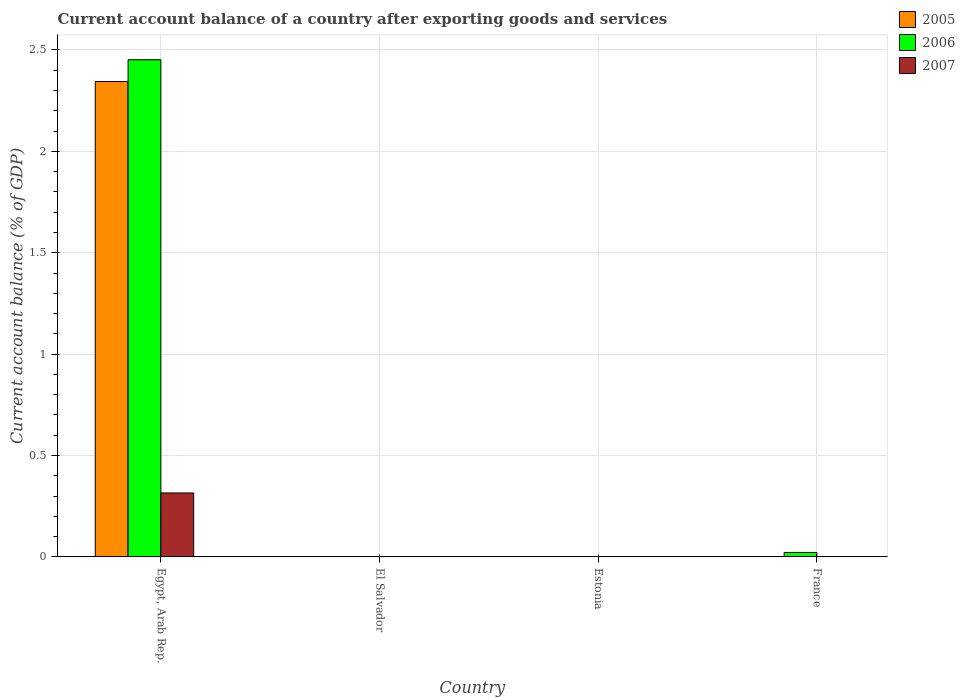How many different coloured bars are there?
Provide a succinct answer. 3. What is the label of the 2nd group of bars from the left?
Your answer should be compact. El Salvador. In how many cases, is the number of bars for a given country not equal to the number of legend labels?
Provide a succinct answer. 3. Across all countries, what is the maximum account balance in 2007?
Give a very brief answer. 0.32. Across all countries, what is the minimum account balance in 2006?
Make the answer very short. 0. In which country was the account balance in 2007 maximum?
Make the answer very short. Egypt, Arab Rep. What is the total account balance in 2006 in the graph?
Your answer should be very brief. 2.47. What is the difference between the account balance in 2006 in Egypt, Arab Rep. and that in France?
Give a very brief answer. 2.43. What is the difference between the account balance in 2005 in Estonia and the account balance in 2006 in Egypt, Arab Rep.?
Your answer should be compact. -2.45. What is the average account balance in 2006 per country?
Your answer should be compact. 0.62. What is the difference between the account balance of/in 2005 and account balance of/in 2006 in Egypt, Arab Rep.?
Provide a short and direct response. -0.11. In how many countries, is the account balance in 2005 greater than 0.2 %?
Make the answer very short. 1. What is the ratio of the account balance in 2006 in Egypt, Arab Rep. to that in France?
Offer a very short reply. 110.38. What is the difference between the highest and the lowest account balance in 2007?
Make the answer very short. 0.32. In how many countries, is the account balance in 2005 greater than the average account balance in 2005 taken over all countries?
Provide a succinct answer. 1. Is it the case that in every country, the sum of the account balance in 2005 and account balance in 2007 is greater than the account balance in 2006?
Your answer should be very brief. No. How many bars are there?
Your answer should be very brief. 4. How many countries are there in the graph?
Offer a terse response. 4. Does the graph contain grids?
Your answer should be very brief. Yes. How are the legend labels stacked?
Provide a short and direct response. Vertical. What is the title of the graph?
Make the answer very short. Current account balance of a country after exporting goods and services. Does "1999" appear as one of the legend labels in the graph?
Keep it short and to the point. No. What is the label or title of the Y-axis?
Offer a very short reply. Current account balance (% of GDP). What is the Current account balance (% of GDP) in 2005 in Egypt, Arab Rep.?
Your answer should be compact. 2.34. What is the Current account balance (% of GDP) in 2006 in Egypt, Arab Rep.?
Offer a very short reply. 2.45. What is the Current account balance (% of GDP) in 2007 in Egypt, Arab Rep.?
Your response must be concise. 0.32. What is the Current account balance (% of GDP) in 2006 in El Salvador?
Your answer should be compact. 0. What is the Current account balance (% of GDP) of 2007 in El Salvador?
Offer a terse response. 0. What is the Current account balance (% of GDP) of 2006 in Estonia?
Provide a short and direct response. 0. What is the Current account balance (% of GDP) of 2005 in France?
Give a very brief answer. 0. What is the Current account balance (% of GDP) of 2006 in France?
Give a very brief answer. 0.02. What is the Current account balance (% of GDP) in 2007 in France?
Your response must be concise. 0. Across all countries, what is the maximum Current account balance (% of GDP) of 2005?
Ensure brevity in your answer.  2.34. Across all countries, what is the maximum Current account balance (% of GDP) in 2006?
Provide a succinct answer. 2.45. Across all countries, what is the maximum Current account balance (% of GDP) of 2007?
Keep it short and to the point. 0.32. Across all countries, what is the minimum Current account balance (% of GDP) in 2005?
Your answer should be very brief. 0. Across all countries, what is the minimum Current account balance (% of GDP) of 2006?
Give a very brief answer. 0. What is the total Current account balance (% of GDP) of 2005 in the graph?
Keep it short and to the point. 2.34. What is the total Current account balance (% of GDP) in 2006 in the graph?
Your answer should be very brief. 2.47. What is the total Current account balance (% of GDP) of 2007 in the graph?
Give a very brief answer. 0.32. What is the difference between the Current account balance (% of GDP) of 2006 in Egypt, Arab Rep. and that in France?
Your answer should be compact. 2.43. What is the difference between the Current account balance (% of GDP) in 2005 in Egypt, Arab Rep. and the Current account balance (% of GDP) in 2006 in France?
Offer a terse response. 2.32. What is the average Current account balance (% of GDP) of 2005 per country?
Offer a very short reply. 0.59. What is the average Current account balance (% of GDP) of 2006 per country?
Ensure brevity in your answer.  0.62. What is the average Current account balance (% of GDP) of 2007 per country?
Provide a succinct answer. 0.08. What is the difference between the Current account balance (% of GDP) in 2005 and Current account balance (% of GDP) in 2006 in Egypt, Arab Rep.?
Your response must be concise. -0.11. What is the difference between the Current account balance (% of GDP) of 2005 and Current account balance (% of GDP) of 2007 in Egypt, Arab Rep.?
Keep it short and to the point. 2.03. What is the difference between the Current account balance (% of GDP) in 2006 and Current account balance (% of GDP) in 2007 in Egypt, Arab Rep.?
Provide a succinct answer. 2.14. What is the ratio of the Current account balance (% of GDP) of 2006 in Egypt, Arab Rep. to that in France?
Make the answer very short. 110.38. What is the difference between the highest and the lowest Current account balance (% of GDP) of 2005?
Provide a short and direct response. 2.34. What is the difference between the highest and the lowest Current account balance (% of GDP) of 2006?
Your response must be concise. 2.45. What is the difference between the highest and the lowest Current account balance (% of GDP) of 2007?
Ensure brevity in your answer.  0.32. 